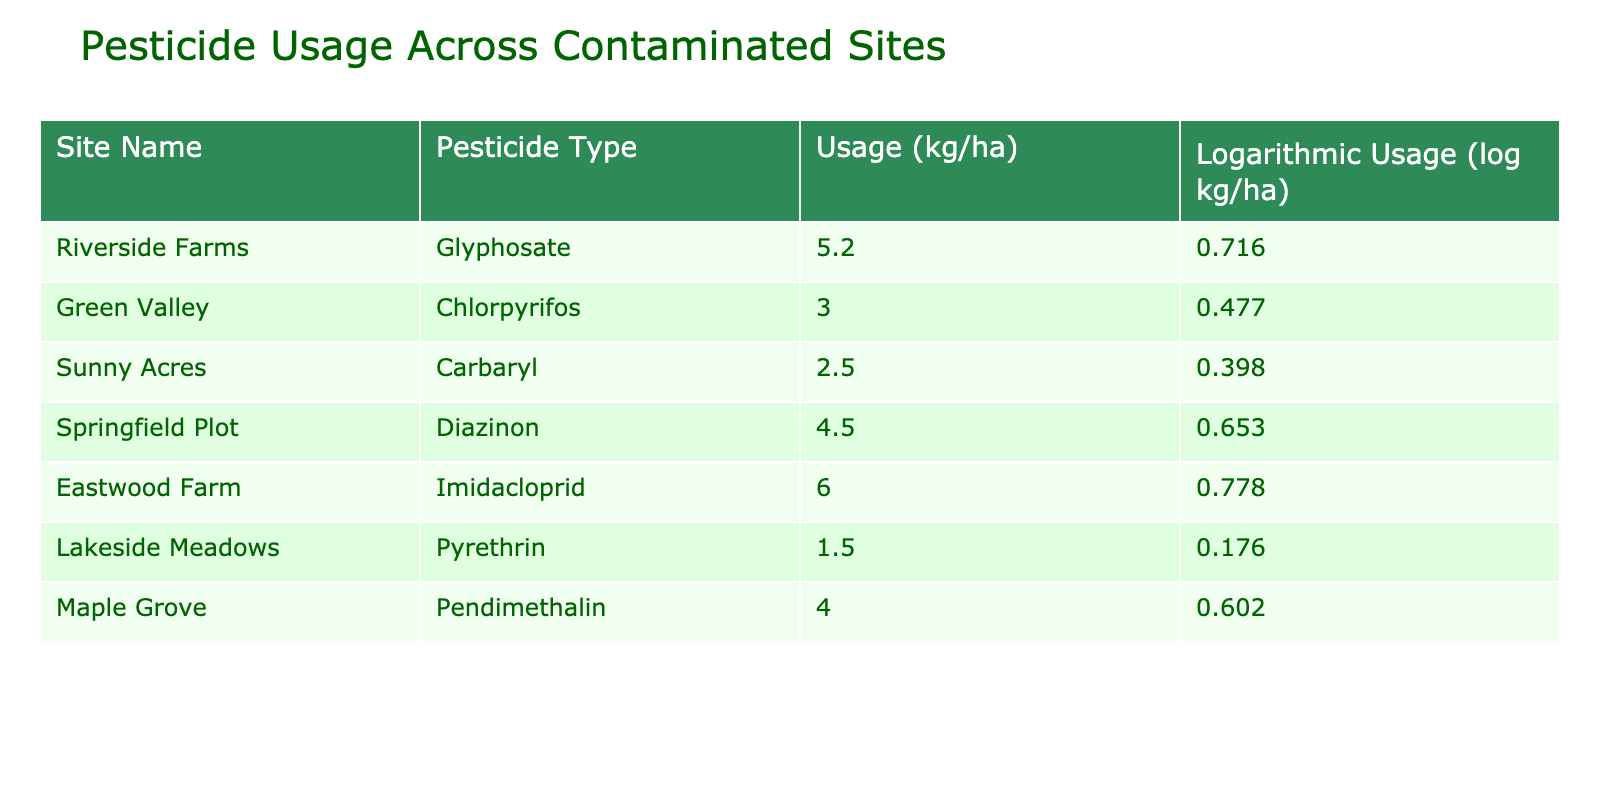What is the pesticide type used at Eastwood Farm? The table indicates that Eastwood Farm uses Imidacloprid as the pesticide type. This information can be found in the "Pesticide Type" column corresponding to Eastwood Farm in the first column.
Answer: Imidacloprid Which site uses the highest amount of pesticide per hectare? Looking at the "Usage (kg/ha)" column, Eastwood Farm has the highest usage at 6.0 kg/ha, which is more than any other site listed.
Answer: Eastwood Farm What is the average pesticide usage across all sites listed? To calculate the average, sum all the usage values: (5.2 + 3.0 + 2.5 + 4.5 + 6.0 + 1.5 + 4.0) = 26.7. There are 7 sites, so the average is 26.7 / 7 = 3.81 kg/ha.
Answer: 3.81 kg/ha Is the pesticide usage at Lakeside Meadows above 2 kg/ha? From the table, Lakeside Meadows has a usage of 1.5 kg/ha which is below 2 kg/ha. Therefore, the statement is false.
Answer: No What is the difference in logarithmic usage between Riverside Farms and Maple Grove? Riverside Farms has a logarithmic usage of 0.716 and Maple Grove has 0.602. The difference is 0.716 - 0.602 = 0.114.
Answer: 0.114 Which pesticide usage is lower: Chlorpyrifos at Green Valley or Pyrethrin at Lakeside Meadows? Green Valley uses 3.0 kg/ha of Chlorpyrifos, while Lakeside Meadows uses 1.5 kg/ha of Pyrethrin. Since 1.5 kg/ha is less than 3.0 kg/ha, Pyrethrin usage is lower.
Answer: Pyrethrin at Lakeside Meadows How many sites reported pesticide usage above 4 kg/ha? The sites with usage above 4 kg/ha are Riverside Farms (5.2), Springfield Plot (4.5), and Eastwood Farm (6.0). That's three sites in total.
Answer: 3 Is the total logarithmic pesticide usage across all sites more than 4? The total logarithmic usage is 0.716 + 0.477 + 0.398 + 0.653 + 0.778 + 0.176 + 0.602 = 3.900. Since 3.900 is less than 4, the answer is false.
Answer: No 